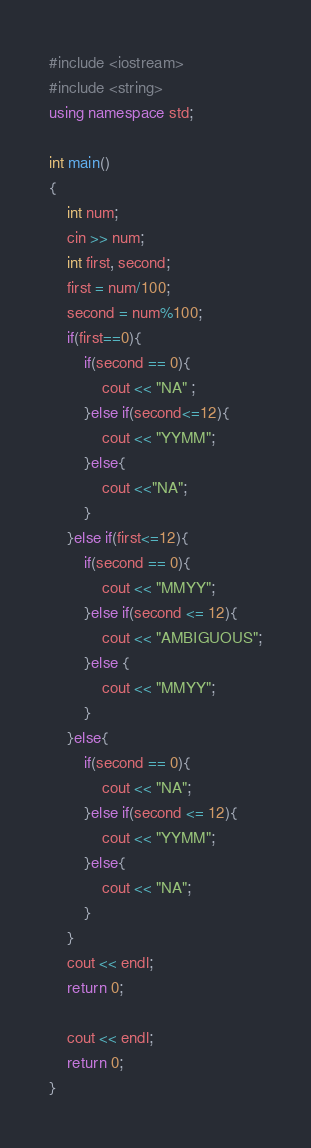Convert code to text. <code><loc_0><loc_0><loc_500><loc_500><_C++_>#include <iostream>
#include <string>
using namespace std;

int main()
{
    int num;
    cin >> num;
    int first, second;
    first = num/100;
    second = num%100;
    if(first==0){
        if(second == 0){
            cout << "NA" ;
        }else if(second<=12){
            cout << "YYMM";
        }else{
            cout <<"NA";
        }
    }else if(first<=12){
        if(second == 0){
            cout << "MMYY";
        }else if(second <= 12){
            cout << "AMBIGUOUS";
        }else {
            cout << "MMYY";
        }
    }else{
        if(second == 0){
            cout << "NA";
        }else if(second <= 12){
            cout << "YYMM";
        }else{
            cout << "NA";
        }
    }
    cout << endl;
    return 0;

    cout << endl;
    return 0;
}</code> 